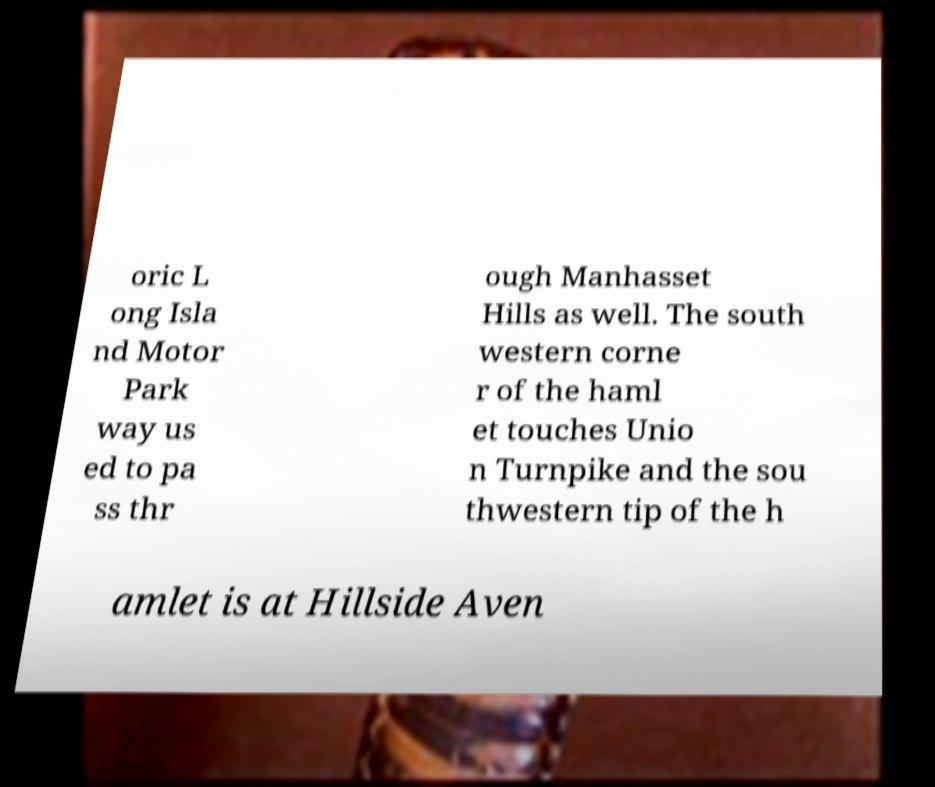Please identify and transcribe the text found in this image. oric L ong Isla nd Motor Park way us ed to pa ss thr ough Manhasset Hills as well. The south western corne r of the haml et touches Unio n Turnpike and the sou thwestern tip of the h amlet is at Hillside Aven 